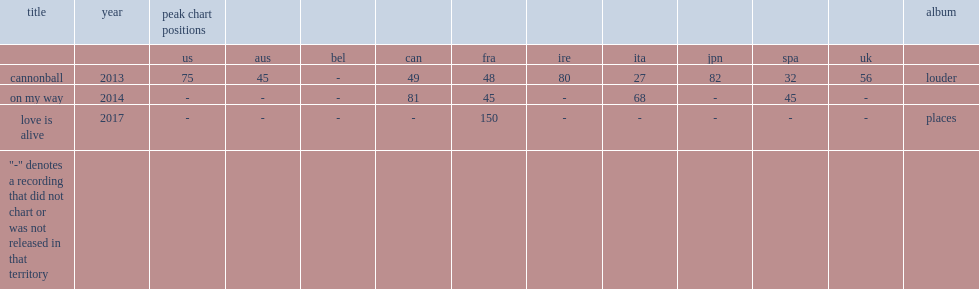Could you parse the entire table? {'header': ['title', 'year', 'peak chart positions', '', '', '', '', '', '', '', '', '', 'album'], 'rows': [['', '', 'us', 'aus', 'bel', 'can', 'fra', 'ire', 'ita', 'jpn', 'spa', 'uk', ''], ['cannonball', '2013', '75', '45', '-', '49', '48', '80', '27', '82', '32', '56', 'louder'], ['on my way', '2014', '-', '-', '-', '81', '45', '-', '68', '-', '45', '-', ''], ['love is alive', '2017', '-', '-', '-', '-', '150', '-', '-', '-', '-', '-', 'places'], ['"-" denotes a recording that did not chart or was not released in that territory', '', '', '', '', '', '', '', '', '', '', '', '']]} In 2017, which album of michele released "love is alive" as the first single from? Places. 